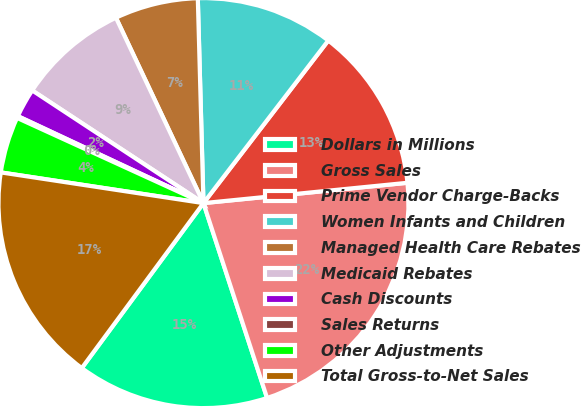Convert chart. <chart><loc_0><loc_0><loc_500><loc_500><pie_chart><fcel>Dollars in Millions<fcel>Gross Sales<fcel>Prime Vendor Charge-Backs<fcel>Women Infants and Children<fcel>Managed Health Care Rebates<fcel>Medicaid Rebates<fcel>Cash Discounts<fcel>Sales Returns<fcel>Other Adjustments<fcel>Total Gross-to-Net Sales<nl><fcel>15.14%<fcel>21.56%<fcel>13.0%<fcel>10.86%<fcel>6.58%<fcel>8.72%<fcel>2.29%<fcel>0.15%<fcel>4.43%<fcel>17.28%<nl></chart> 